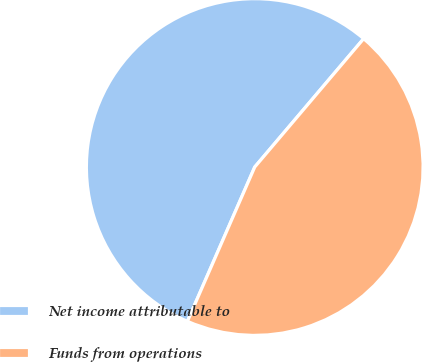<chart> <loc_0><loc_0><loc_500><loc_500><pie_chart><fcel>Net income attributable to<fcel>Funds from operations<nl><fcel>54.65%<fcel>45.35%<nl></chart> 